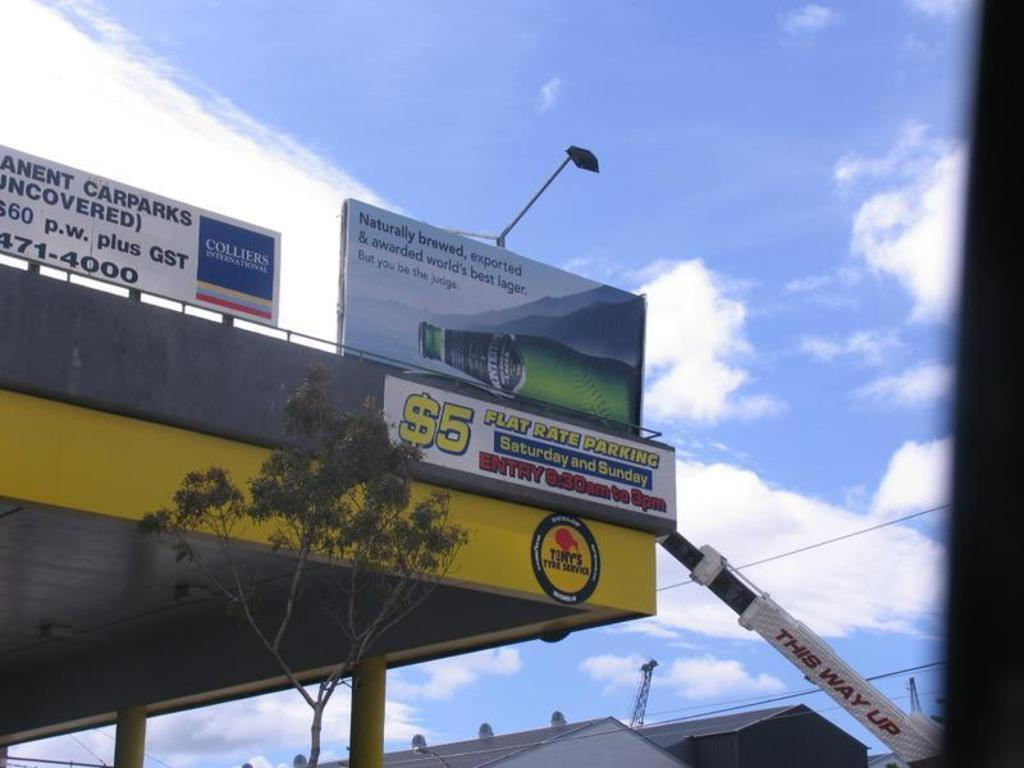<image>
Summarize the visual content of the image. The price is $5 for parking on Saturday and Sunday. 